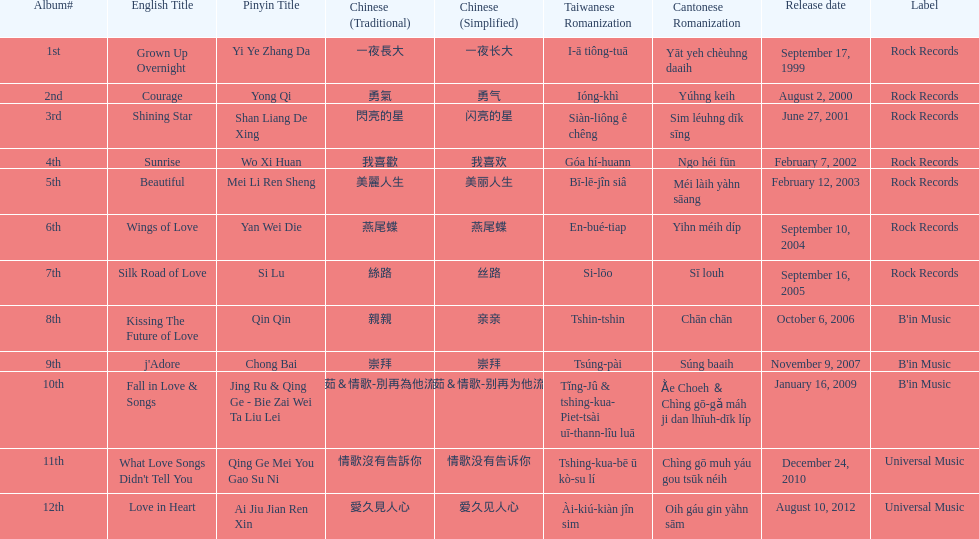Which song is listed first in the table? Grown Up Overnight. 